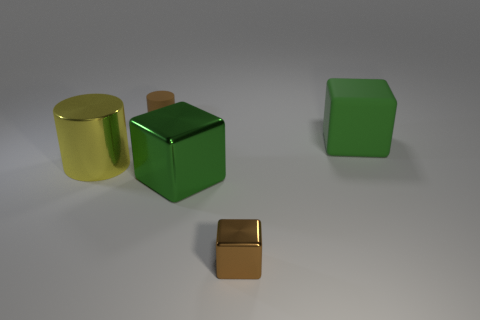How many things are either small brown objects that are on the right side of the large green shiny block or brown things that are in front of the green rubber object?
Your answer should be compact. 1. The brown thing that is made of the same material as the yellow thing is what size?
Keep it short and to the point. Small. What number of metal objects are big blocks or small blocks?
Give a very brief answer. 2. How big is the yellow metallic thing?
Your response must be concise. Large. Is the size of the yellow cylinder the same as the brown cube?
Your answer should be compact. No. What is the material of the block behind the yellow metallic thing?
Ensure brevity in your answer.  Rubber. What is the material of the other big green thing that is the same shape as the green metal object?
Provide a short and direct response. Rubber. There is a large metallic object to the left of the matte cylinder; are there any big things behind it?
Keep it short and to the point. Yes. Do the brown rubber thing and the big yellow thing have the same shape?
Offer a terse response. Yes. What shape is the green thing that is made of the same material as the small cylinder?
Keep it short and to the point. Cube. 